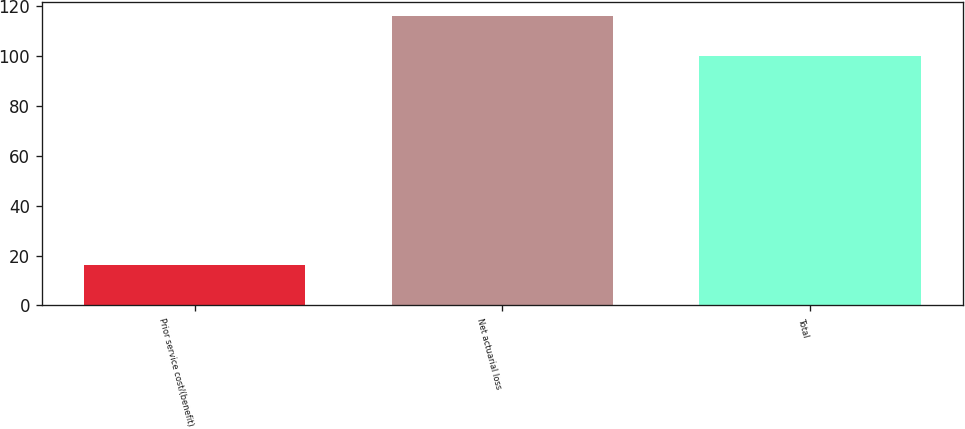Convert chart to OTSL. <chart><loc_0><loc_0><loc_500><loc_500><bar_chart><fcel>Prior service cost/(benefit)<fcel>Net actuarial loss<fcel>Total<nl><fcel>16<fcel>116<fcel>100<nl></chart> 